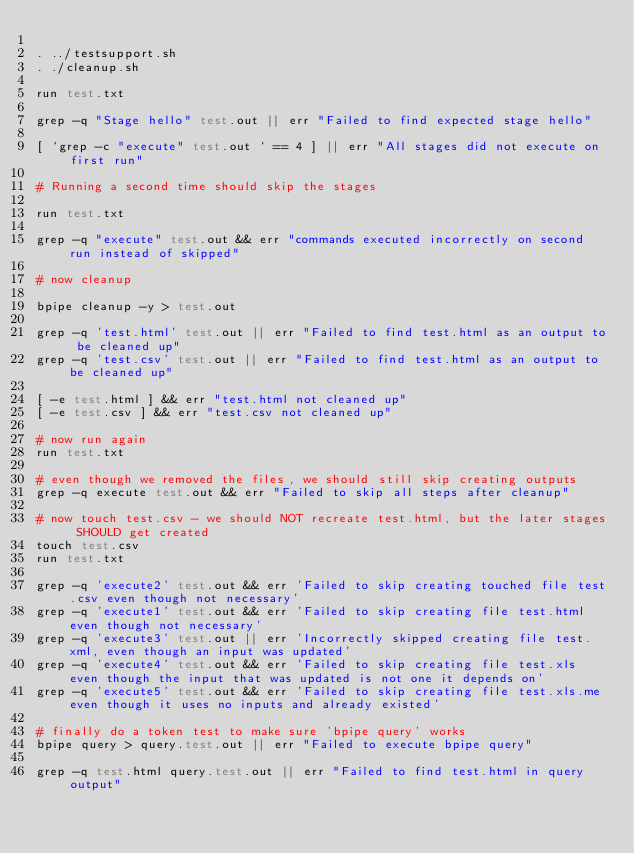<code> <loc_0><loc_0><loc_500><loc_500><_Bash_>
. ../testsupport.sh  
. ./cleanup.sh

run test.txt

grep -q "Stage hello" test.out || err "Failed to find expected stage hello"

[ `grep -c "execute" test.out ` == 4 ] || err "All stages did not execute on first run"

# Running a second time should skip the stages

run test.txt

grep -q "execute" test.out && err "commands executed incorrectly on second run instead of skipped"

# now cleanup

bpipe cleanup -y > test.out

grep -q 'test.html' test.out || err "Failed to find test.html as an output to be cleaned up"
grep -q 'test.csv' test.out || err "Failed to find test.html as an output to be cleaned up"

[ -e test.html ] && err "test.html not cleaned up"
[ -e test.csv ] && err "test.csv not cleaned up"

# now run again
run test.txt

# even though we removed the files, we should still skip creating outputs
grep -q execute test.out && err "Failed to skip all steps after cleanup"

# now touch test.csv - we should NOT recreate test.html, but the later stages SHOULD get created
touch test.csv
run test.txt

grep -q 'execute2' test.out && err 'Failed to skip creating touched file test.csv even though not necessary'
grep -q 'execute1' test.out && err 'Failed to skip creating file test.html even though not necessary'
grep -q 'execute3' test.out || err 'Incorrectly skipped creating file test.xml, even though an input was updated'
grep -q 'execute4' test.out && err 'Failed to skip creating file test.xls even though the input that was updated is not one it depends on'
grep -q 'execute5' test.out && err 'Failed to skip creating file test.xls.me even though it uses no inputs and already existed'

# finally do a token test to make sure 'bpipe query' works
bpipe query > query.test.out || err "Failed to execute bpipe query"

grep -q test.html query.test.out || err "Failed to find test.html in query output"

</code> 